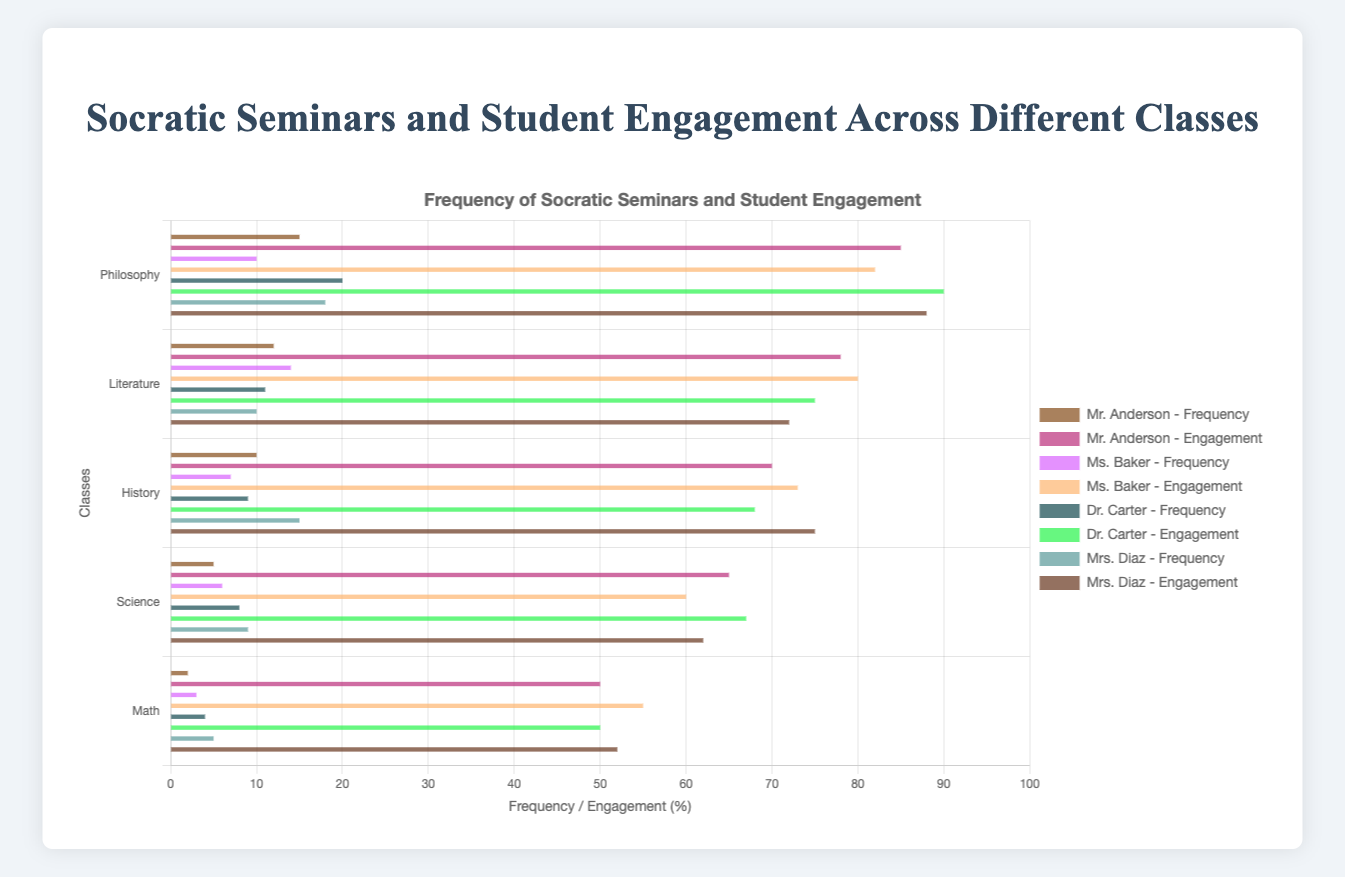Which teacher conducted the most Socratic seminars in Philosophy? Looking at the bar heights and labels, Dr. Carter conducted the most Socratic seminars in Philosophy with 20 seminars.
Answer: Dr. Carter Who had the highest student engagement in Math? Analyzing the bars for Math, Ms. Baker showed the highest student engagement in Math with 55%.
Answer: Ms. Baker In which subject did Mr. Anderson have the highest student engagement, and what was the engagement percentage? Reviewing Mr. Anderson's engagement data across subjects, Philosophy has the highest student engagement at 85%.
Answer: Philosophy, 85% Which class had the lowest frequency of Socratic seminars overall and which teacher conducted it? Analyzing the bars, Math had the lowest frequency, and Mr. Anderson conducted the least with 2 seminars.
Answer: Math, Mr. Anderson What is the combined frequency of Socratic seminars in Science for all teachers? Summing up the seminar frequencies in Science: Mr. Anderson (5) + Ms. Baker (6) + Dr. Carter (8) + Mrs. Diaz (9) = 28 seminars.
Answer: 28 Which class sees the most consistent level of student engagement across all teachers? Comparing student engagement levels, Philosophy values are close across all teachers: Mr. Anderson (85), Ms. Baker (82), Dr. Carter (90), and Mrs. Diaz (88).
Answer: Philosophy What is the total student engagement for History classes conducted by Mr. Anderson and Ms. Baker combined? Summing up student engagement for History from Mr. Anderson (70%) and Ms. Baker (73%) = 143%.
Answer: 143% Which subject shows the greatest disparity in Socratic seminar frequency among the teachers? Examining the frequency bars, Philosophy shows the greatest disparity with values ranging widely from 10 (Ms. Baker) to 20 (Dr. Carter).
Answer: Philosophy How much higher is the student engagement in Literature for Ms. Baker compared to Dr. Carter? Subtracting the student engagement values: Ms. Baker (80) - Dr. Carter (75) = 5%.
Answer: 5% Which teacher had the lowest average student engagement across all classes? Calculating the average engagement:
Mr. Anderson: (85+78+70+65+50)/5 = 69.6%
Ms. Baker: (82+80+73+60+55)/5 = 70%
Dr. Carter: (90+75+68+67+50)/5 = 70%
Mrs. Diaz: (88+72+75+62+52)/5 = 69.8%
Mr. Anderson has the lowest average with 69.6%.
Answer: Mr. Anderson 